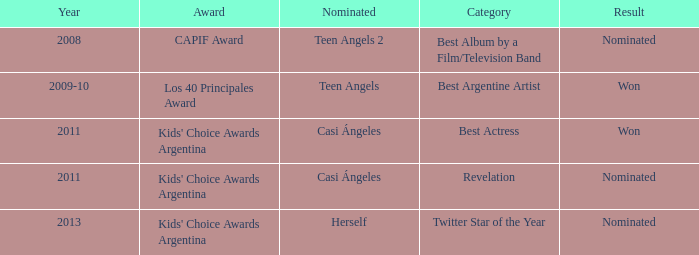Would you mind parsing the complete table? {'header': ['Year', 'Award', 'Nominated', 'Category', 'Result'], 'rows': [['2008', 'CAPIF Award', 'Teen Angels 2', 'Best Album by a Film/Television Band', 'Nominated'], ['2009-10', 'Los 40 Principales Award', 'Teen Angels', 'Best Argentine Artist', 'Won'], ['2011', "Kids' Choice Awards Argentina", 'Casi Ángeles', 'Best Actress', 'Won'], ['2011', "Kids' Choice Awards Argentina", 'Casi Ángeles', 'Revelation', 'Nominated'], ['2013', "Kids' Choice Awards Argentina", 'Herself', 'Twitter Star of the Year', 'Nominated']]} For what award was there a nomination for Best Actress? Kids' Choice Awards Argentina. 